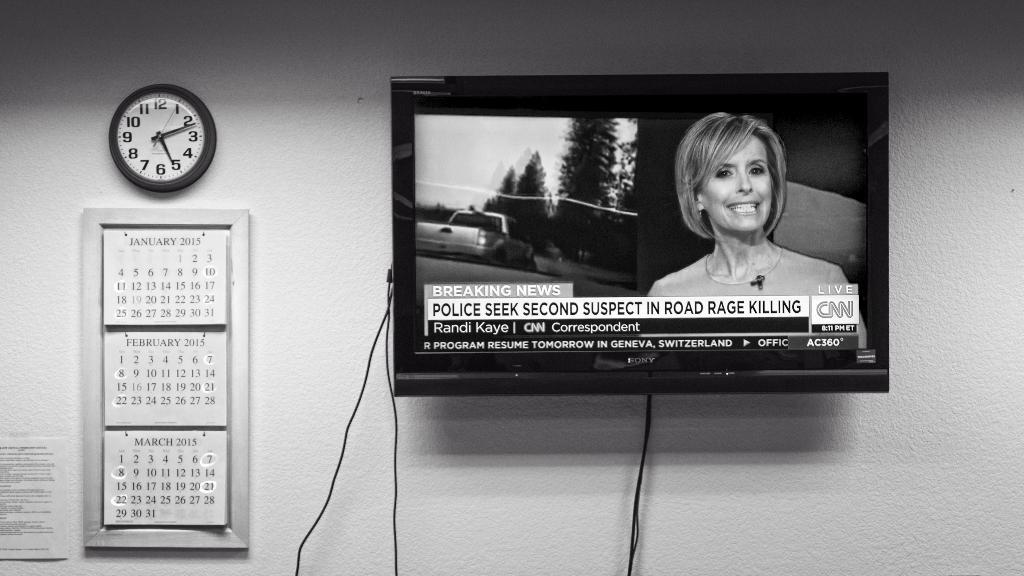<image>
Give a short and clear explanation of the subsequent image. The televisiion is turned to the CNN channel 